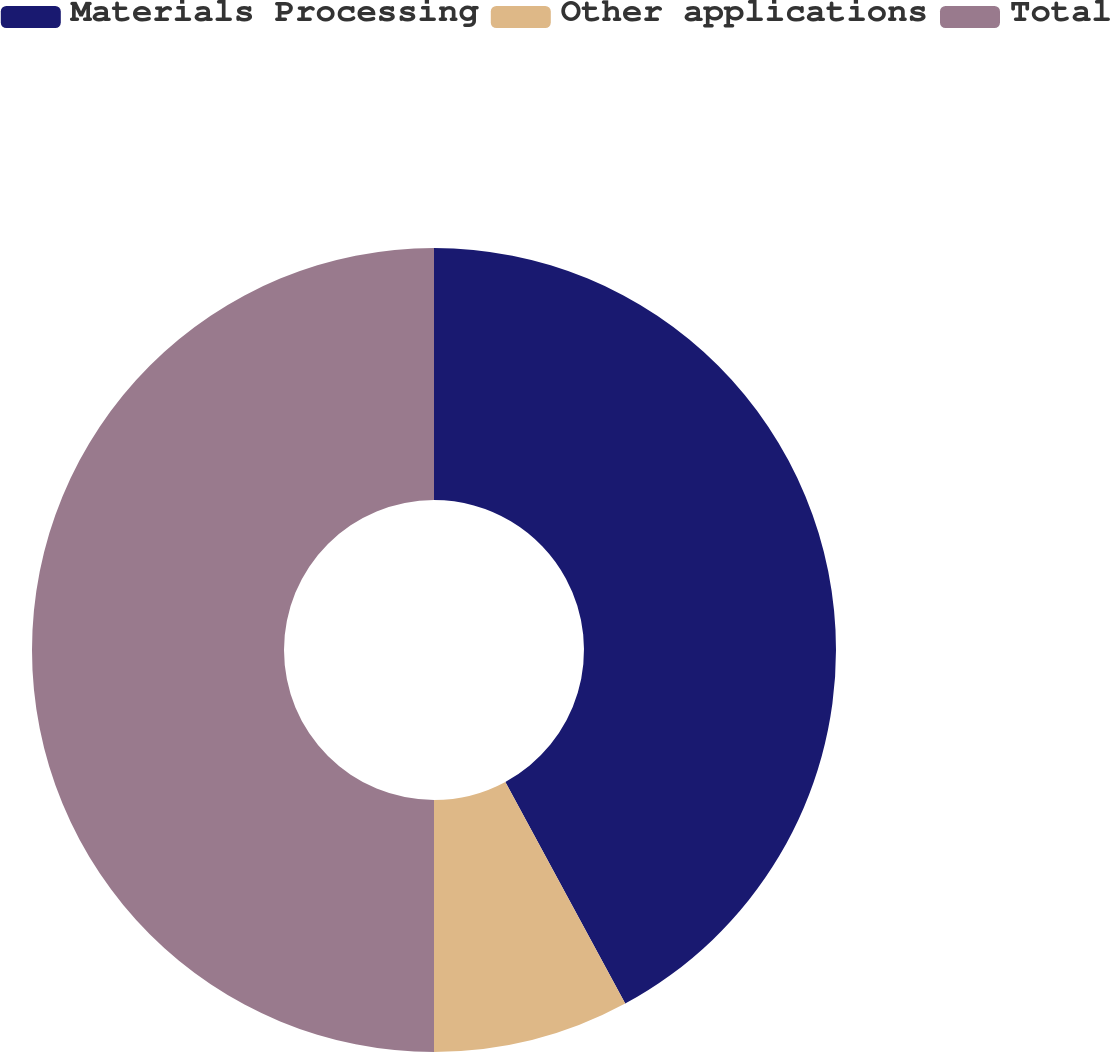Convert chart. <chart><loc_0><loc_0><loc_500><loc_500><pie_chart><fcel>Materials Processing<fcel>Other applications<fcel>Total<nl><fcel>42.11%<fcel>7.89%<fcel>50.0%<nl></chart> 